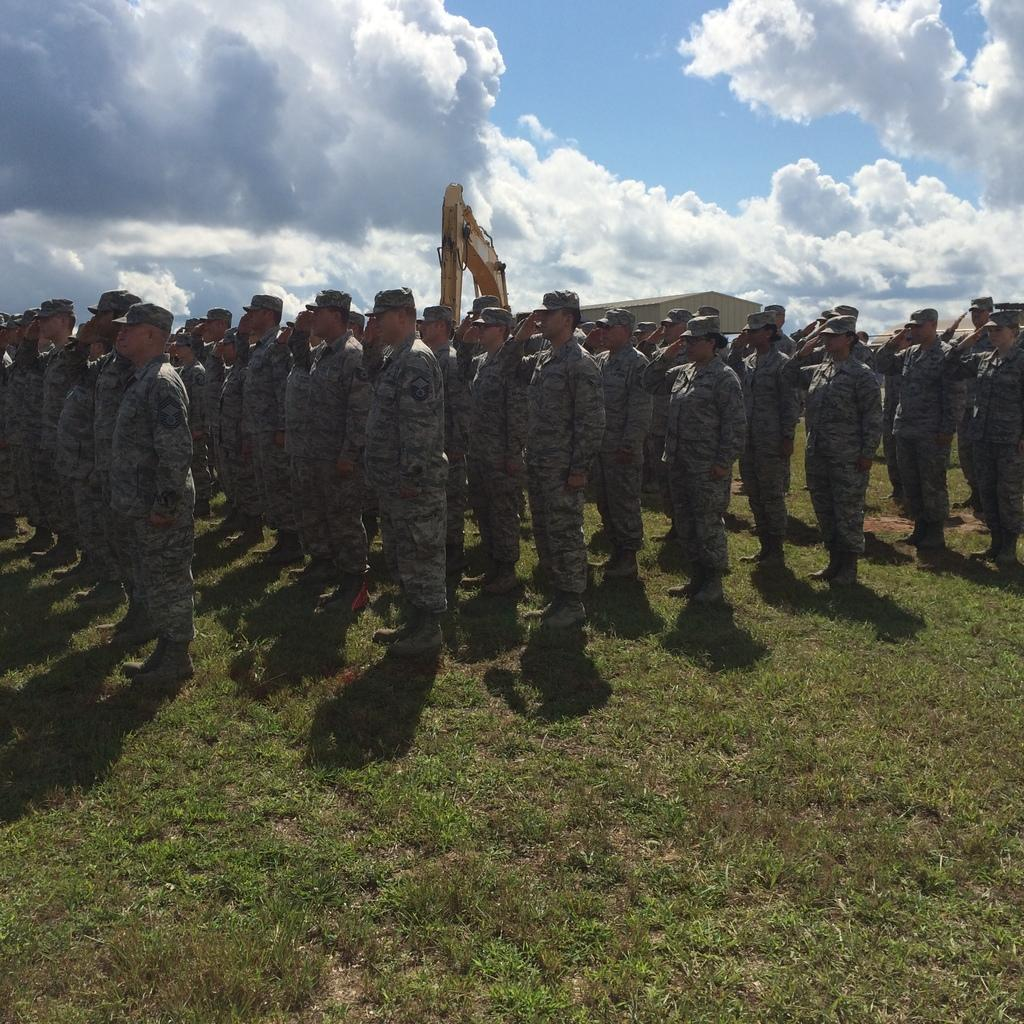What is the main subject of the image? The main subject of the image is a group of soldiers. Where are the soldiers located in the image? The soldiers are on the ground. What can be seen in the background of the image? There is a crane, a shed, and the sky visible in the background of the image. Can you describe the time of day when the image was taken? The image appears to be taken during the day. What direction are the soldiers facing in the image? The provided facts do not specify the direction the soldiers are facing, so it cannot be determined from the image. Is there a doctor present in the image? There is no mention of a doctor in the provided facts, and therefore no doctor is present in the image. 